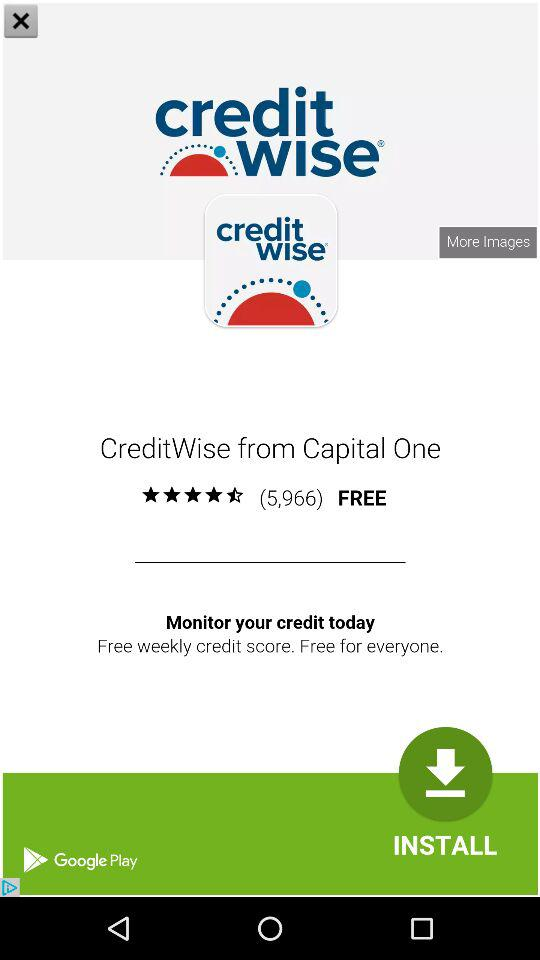Where can we download this app? You can download it from "Google Play". 